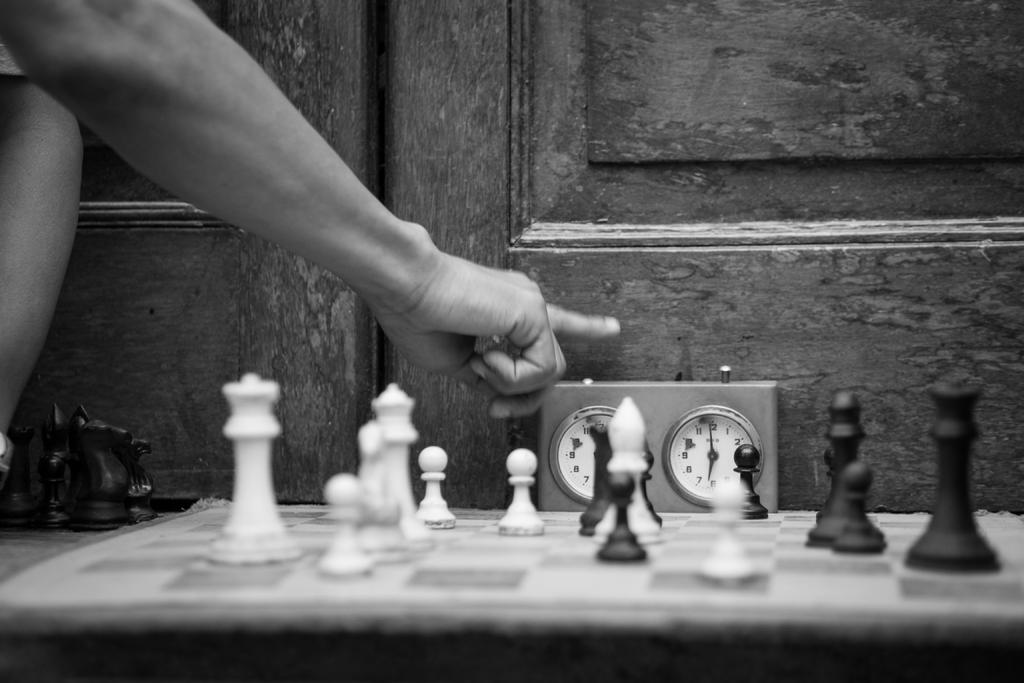Who is the person in the image? There is a man in the image. What is the man doing in the image? The man is playing chess. What is the main object on which the man and his activity are focused? There is a chess board in the image. What pieces are used in the game of chess that are visible on the board? Chess coins are present on the chess board. What can be seen in the background of the image? There is a wooden door and a timer in the background of the image. How many buckets of water does the man use to mark his territory in the image? There are no buckets of water or any indication of marking territory in the image. 